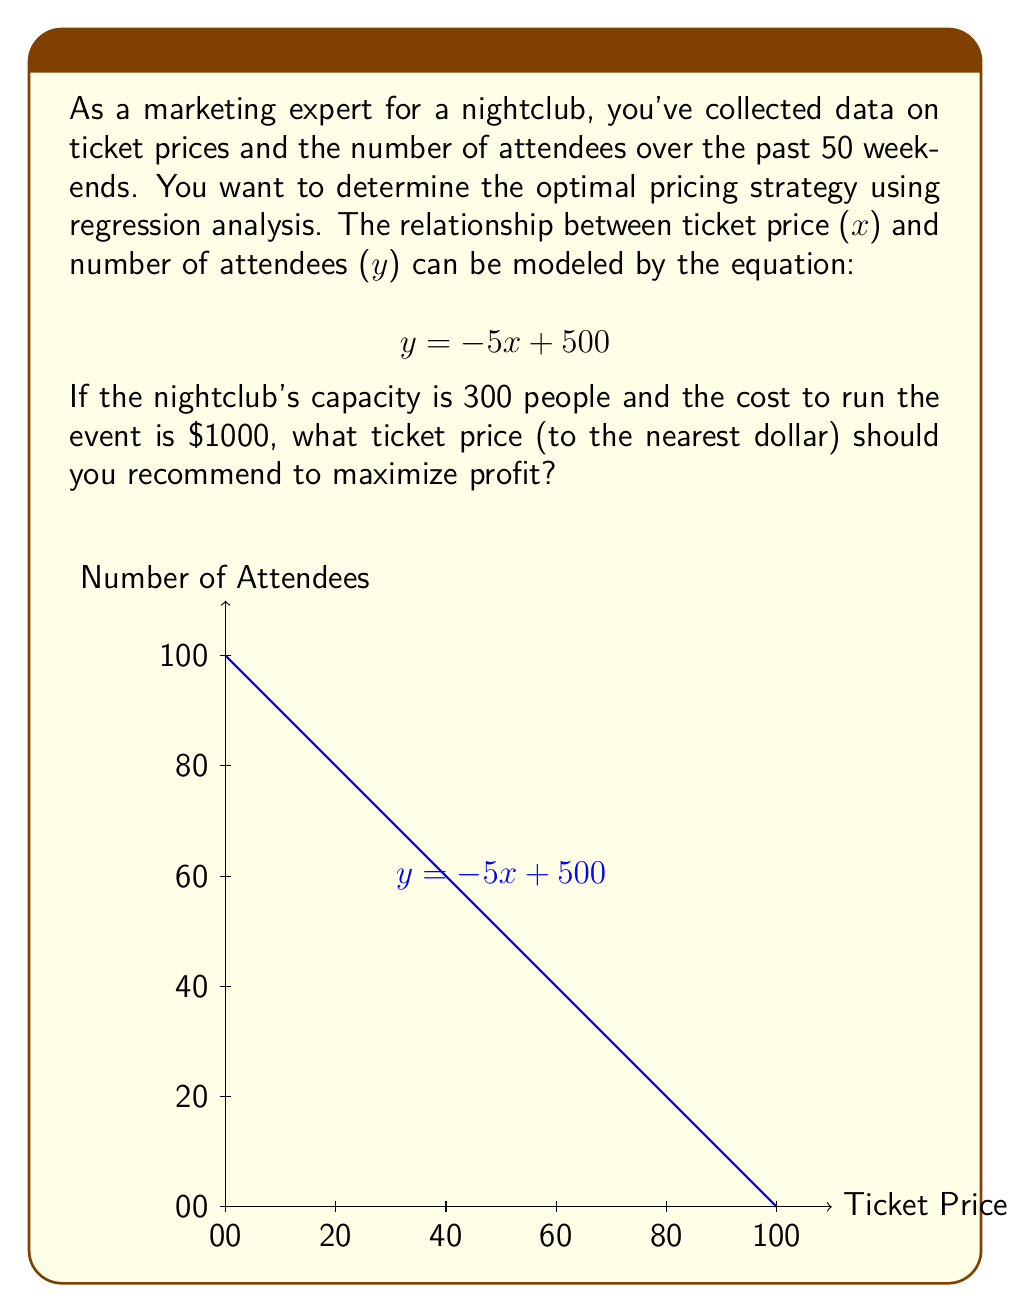Could you help me with this problem? Let's approach this step-by-step:

1) First, we need to set up the profit function. Profit is revenue minus cost:
   $$ \text{Profit} = \text{Revenue} - \text{Cost} $$

2) Revenue is the product of ticket price and number of attendees:
   $$ \text{Revenue} = x \cdot y = x \cdot (-5x + 500) $$

3) The cost is fixed at $1000, so our profit function is:
   $$ \text{Profit} = x(-5x + 500) - 1000 = -5x^2 + 500x - 1000 $$

4) To find the maximum profit, we need to find the vertex of this parabola. The x-coordinate of the vertex will give us the optimal ticket price.

5) For a quadratic function $ax^2 + bx + c$, the x-coordinate of the vertex is given by $-b/(2a)$. In our case, $a=-5$, $b=500$:
   $$ x = -\frac{500}{2(-5)} = 50 $$

6) However, we need to check if this results in more than 300 attendees (the club's capacity):
   $$ y = -5(50) + 500 = 250 $$

   This is within the capacity, so $50 is our optimal price.

7) To verify this maximizes profit:
   $$ \text{Profit} = 50(250) - 1000 = 11,500 $$

8) Rounding to the nearest dollar gives us $50.
Answer: $50 